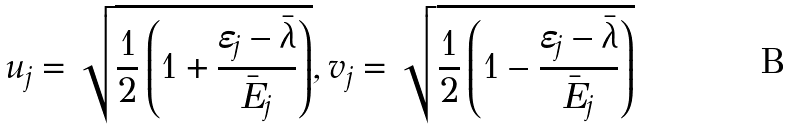<formula> <loc_0><loc_0><loc_500><loc_500>u _ { j } = \sqrt { \frac { 1 } { 2 } \left ( 1 + \frac { \varepsilon _ { j } - \bar { \lambda } } { \bar { E } _ { j } } \right ) } , v _ { j } = \sqrt { \frac { 1 } { 2 } \left ( 1 - \frac { \varepsilon _ { j } - \bar { \lambda } } { \bar { E } _ { j } } \right ) }</formula> 